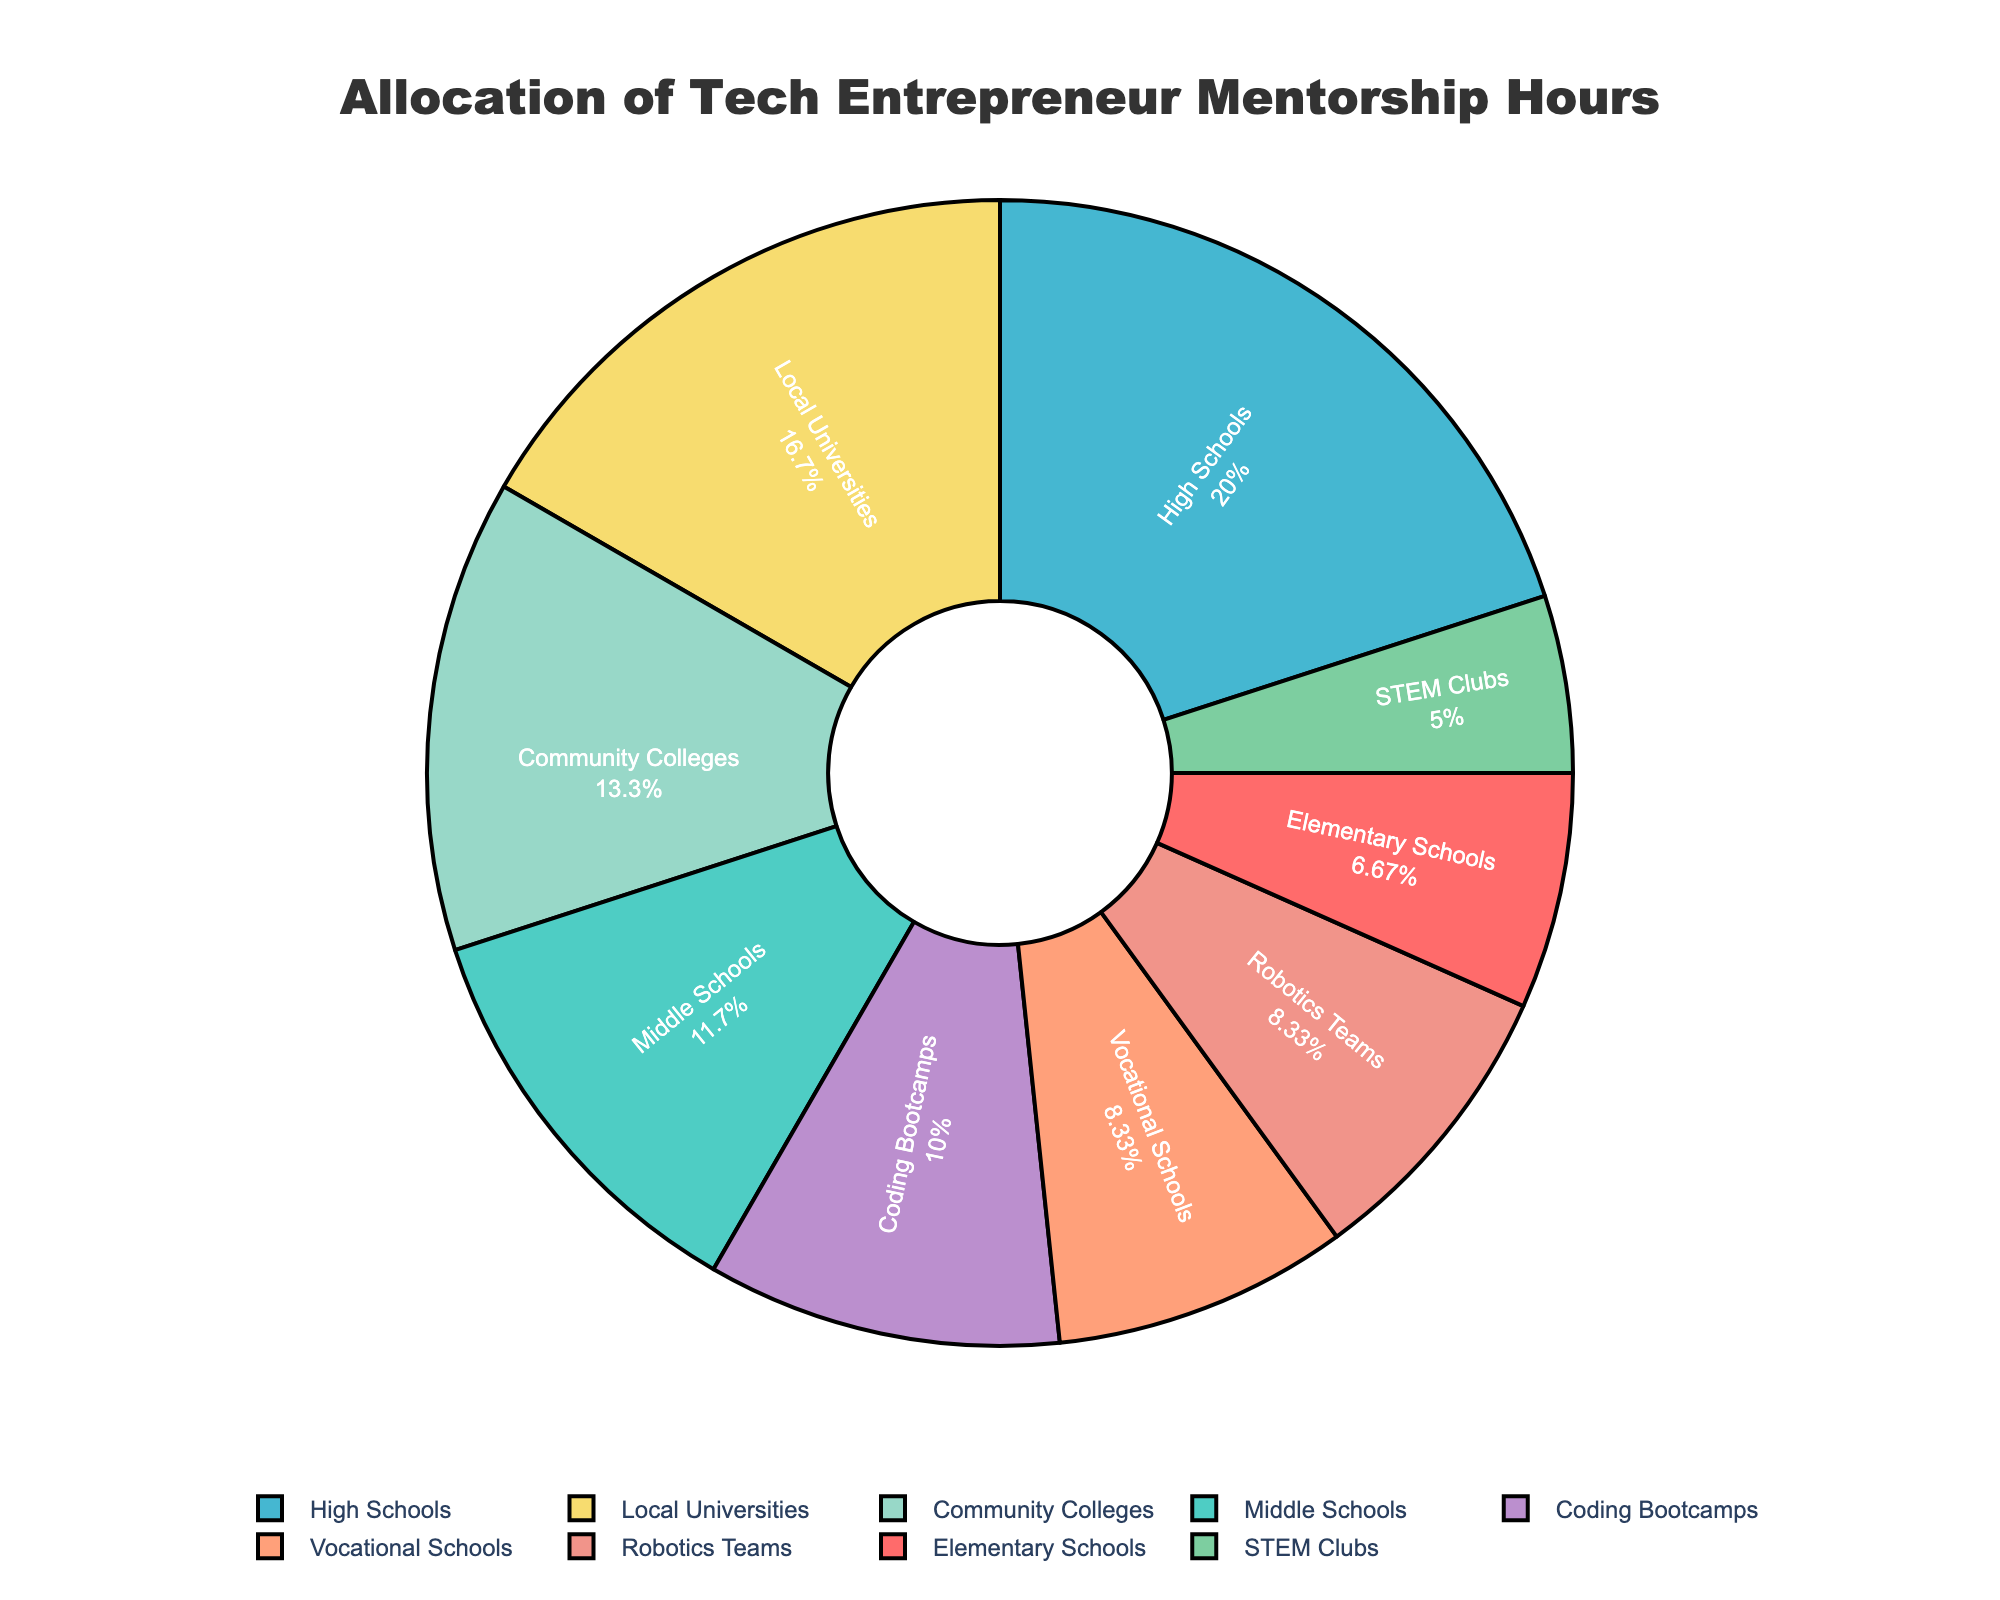What's the school level with the highest allocation of mentorship hours? Elementary Schools have 20 hours, Middle Schools have 35 hours, High Schools have 60 hours, Vocational Schools have 25 hours, Community Colleges have 40 hours, Local Universities have 50 hours, Coding Bootcamps have 30 hours, STEM Clubs have 15 hours, and Robotics Teams have 25 hours. The highest value is 60 hours for High Schools.
Answer: High Schools What's the total number of mentorship hours allocated to Community Colleges and Coding Bootcamps combined? Community Colleges have 40 hours and Coding Bootcamps have 30 hours. So, 40 + 30 = 70 hours.
Answer: 70 Is the allocation of mentorship hours to Elementary Schools greater than that to STEM Clubs? Elementary Schools have 20 hours, and STEM Clubs have 15 hours. Since 20 > 15, Elementary Schools have more hours.
Answer: Yes Which type of schools have equal allocation of mentorship hours? Vocational Schools and Robotics Teams both have 25 hours allocated.
Answer: Vocational Schools and Robotics Teams How many more mentorship hours are allocated to High Schools compared to Elementary Schools? High Schools have 60 hours, and Elementary Schools have 20 hours. The difference is 60 - 20 = 40 hours.
Answer: 40 What is the percentage of total mentorship hours attributed to Local Universities? Total hours summarize to 300 (20+35+60+25+40+50+30+15+25). Local Universities have 50 hours. The percentage is (50 / 300) * 100 ≈ 16.67%.
Answer: 16.67% List the school levels that have less than 30 mentorship hours allocated. Elementary Schools (20 hours), STEM Clubs (15 hours), and Robotics Teams (25 hours) all have less than 30 hours.
Answer: Elementary Schools, STEM Clubs, Robotics Teams Is the sum of mentorship hours for Vocational Schools and STEM Clubs more, less, or equal to the hours for Local Universities? Vocational Schools have 25 hours, and STEM Clubs have 15 hours. Their sum is 25 + 15 = 40 hours. Local Universities have 50 hours. 40 is less than 50.
Answer: Less What color represents Local Universities in the pie chart? The visual attribute for Local Universities in the pie chart is identified by its segment's color, which we need to check against the coding created: it's represented in the order of the color list, and Local Universities are the 6th category listed, the color for which in turn matches the sixth color in the color list, corresponding to a shade of purple in the palette provided.
Answer: Purple 